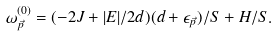<formula> <loc_0><loc_0><loc_500><loc_500>\omega _ { \vec { p } } ^ { ( 0 ) } = ( - 2 J + | E | / 2 d ) ( d + \epsilon _ { \vec { p } } ) / S + H / S .</formula> 